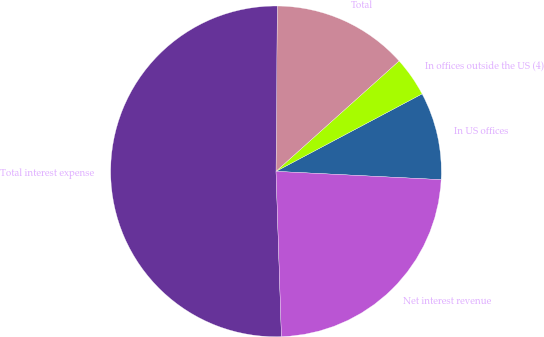<chart> <loc_0><loc_0><loc_500><loc_500><pie_chart><fcel>In US offices<fcel>In offices outside the US (4)<fcel>Total<fcel>Total interest expense<fcel>Net interest revenue<nl><fcel>8.56%<fcel>3.88%<fcel>13.24%<fcel>50.65%<fcel>23.68%<nl></chart> 